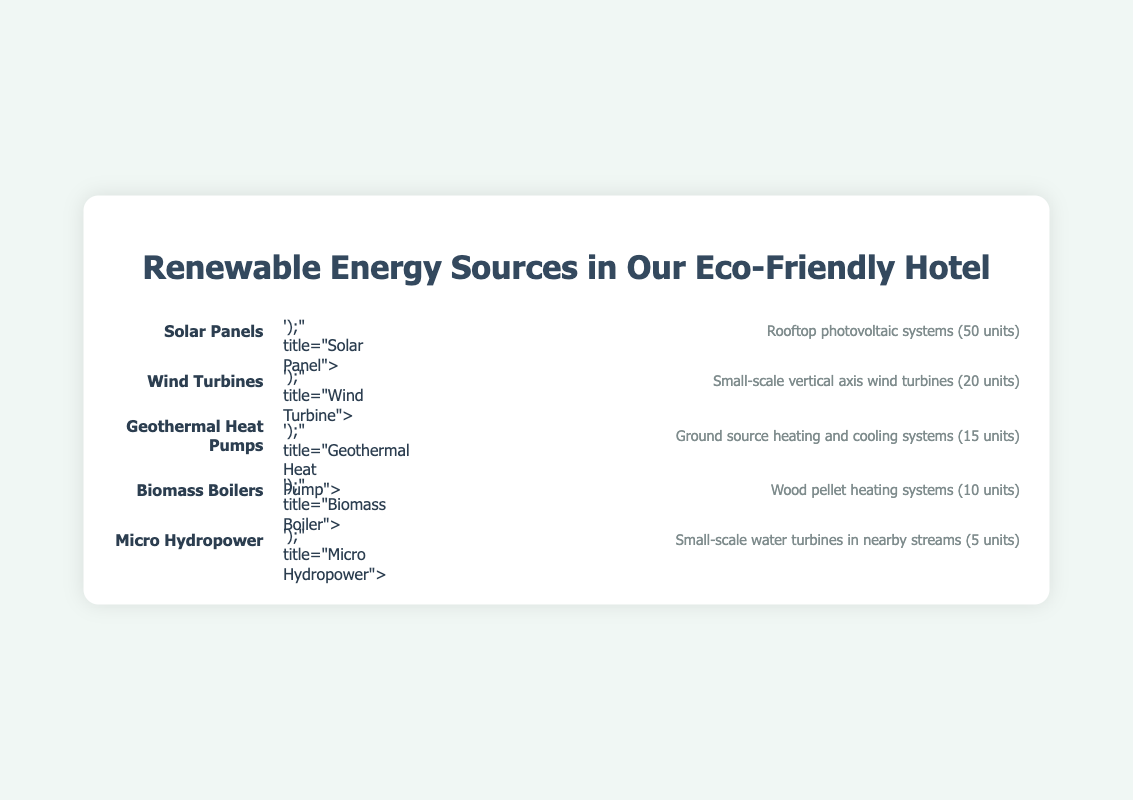What is the title of the figure? The title is located at the top of the figure and provides a summary or purpose of the information presented, which is "Renewable Energy Sources in Our Eco-Friendly Hotel".
Answer: Renewable Energy Sources in Our Eco-Friendly Hotel How many solar panel units are utilized in the hotels? Look at the row labeled "Solar Panels" to see the number of icons representing units.
Answer: 50 Which renewable energy source has the fewest units? Compare the number of units for each renewable energy source presented in the rows. "Micro Hydropower" has the fewest units indicated by 5 icons.
Answer: Micro Hydropower What renewable energy sources are used for heating systems? Check the descriptions in the respective rows to identify any heating systems. "Geothermal Heat Pumps" and "Biomass Boilers" both indicate heating systems in their descriptions.
Answer: Geothermal Heat Pumps and Biomass Boilers How many units of renewable energy sources are used in total? Add up the units from each source: Solar Panels (50) + Wind Turbines (20) + Geothermal Heat Pumps (15) + Biomass Boilers (10) + Micro Hydropower (5). The total is 100 units.
Answer: 100 Which energy source has more units, Wind Turbines or Biomass Boilers? Compare the number of units for "Wind Turbines" which is 20, and "Biomass Boilers" which is 10.
Answer: Wind Turbines What is the difference in the number of units between Solar Panels and Geothermal Heat Pumps? Subtract the units of Geothermal Heat Pumps (15) from Solar Panels (50): 50 - 15.
Answer: 35 What description is given for Micro Hydropower? Read the description in the row labeled "Micro Hydropower".
Answer: Small-scale water turbines in nearby streams Rank the renewable energy sources from most to least utilized. Order the sources based on their number of units: Solar Panels (50), Wind Turbines (20), Geothermal Heat Pumps (15), Biomass Boilers (10), Micro Hydropower (5).
Answer: Solar Panels, Wind Turbines, Geothermal Heat Pumps, Biomass Boilers, Micro Hydropower 